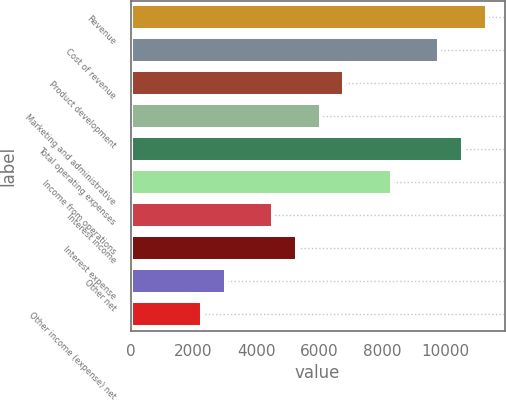Convert chart to OTSL. <chart><loc_0><loc_0><loc_500><loc_500><bar_chart><fcel>Revenue<fcel>Cost of revenue<fcel>Product development<fcel>Marketing and administrative<fcel>Total operating expenses<fcel>Income from operations<fcel>Interest income<fcel>Interest expense<fcel>Other net<fcel>Other income (expense) net<nl><fcel>11329.3<fcel>9818.77<fcel>6797.69<fcel>6042.42<fcel>10574<fcel>8308.23<fcel>4531.88<fcel>5287.15<fcel>3021.34<fcel>2266.07<nl></chart> 